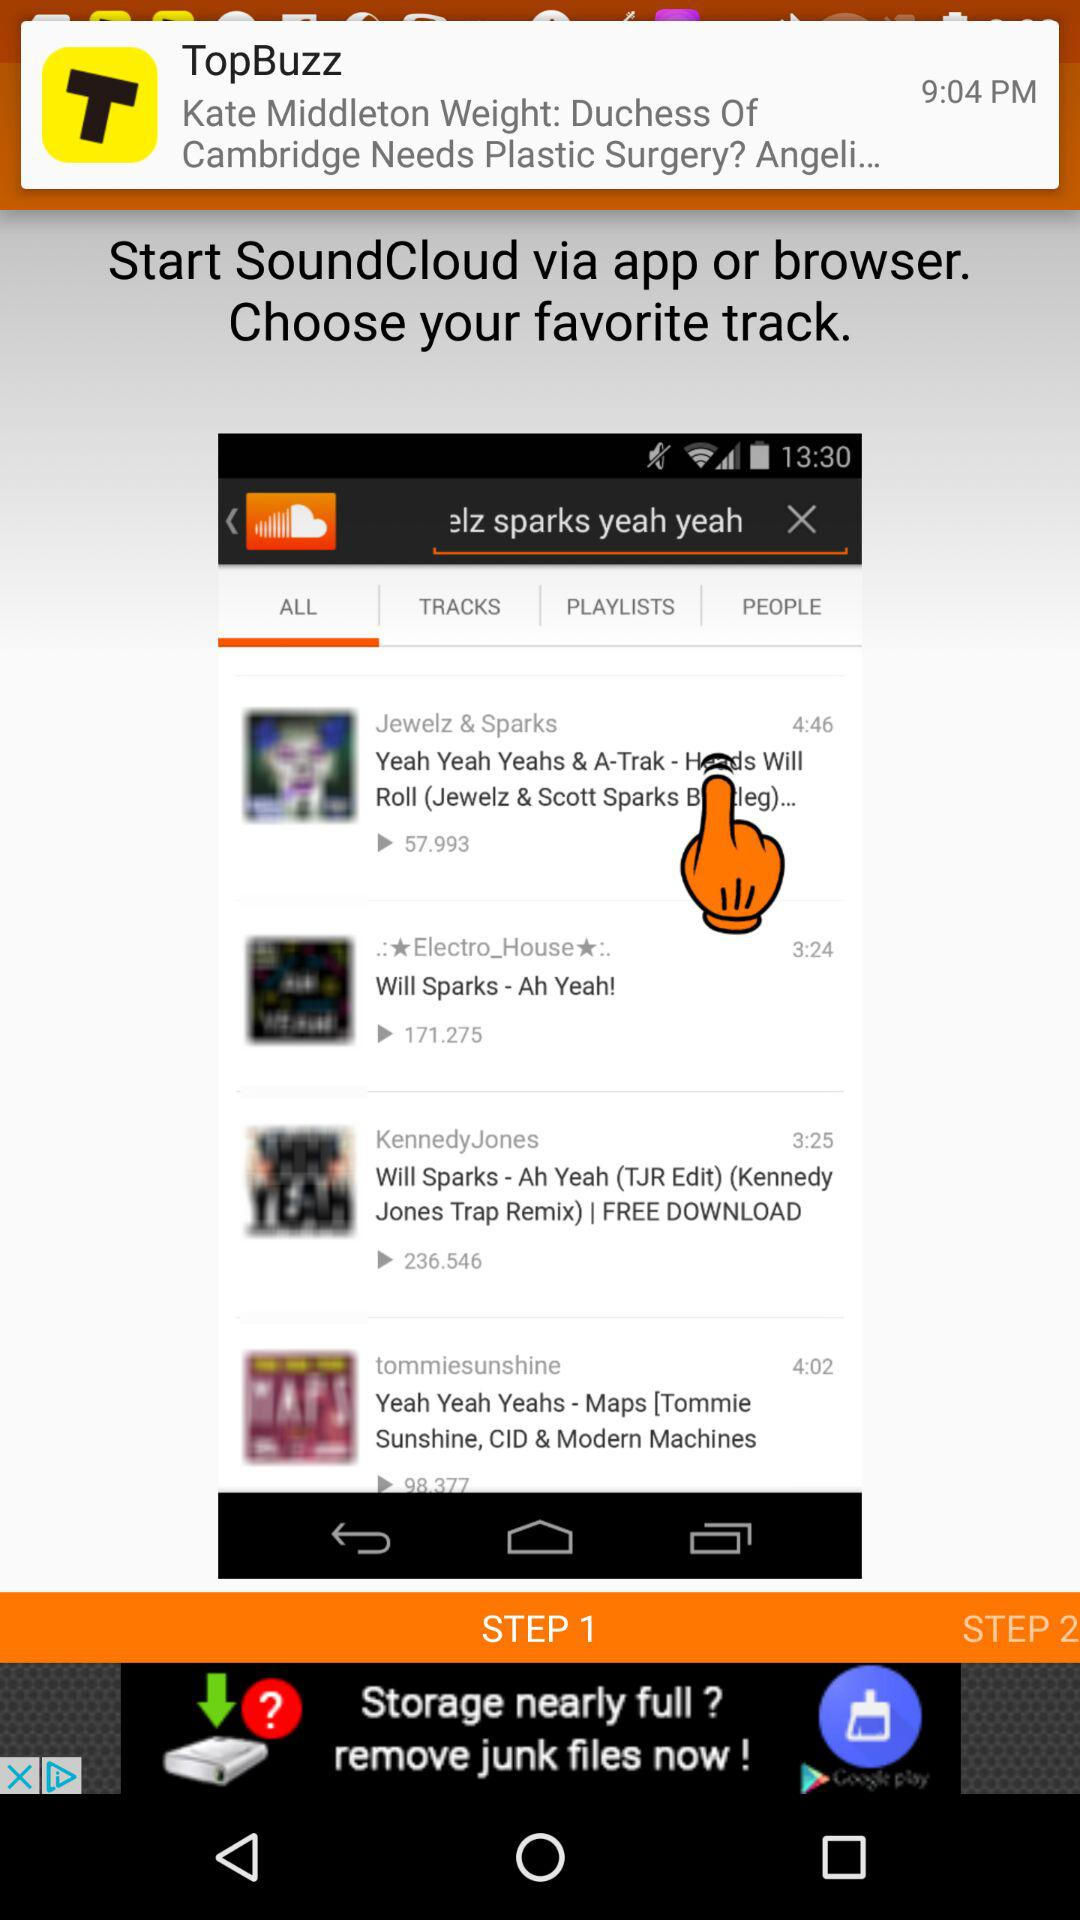What's the length of the "Will Sparks - Ah Yeah!" video? The length of the video is 3 minutes and 24 seconds. 